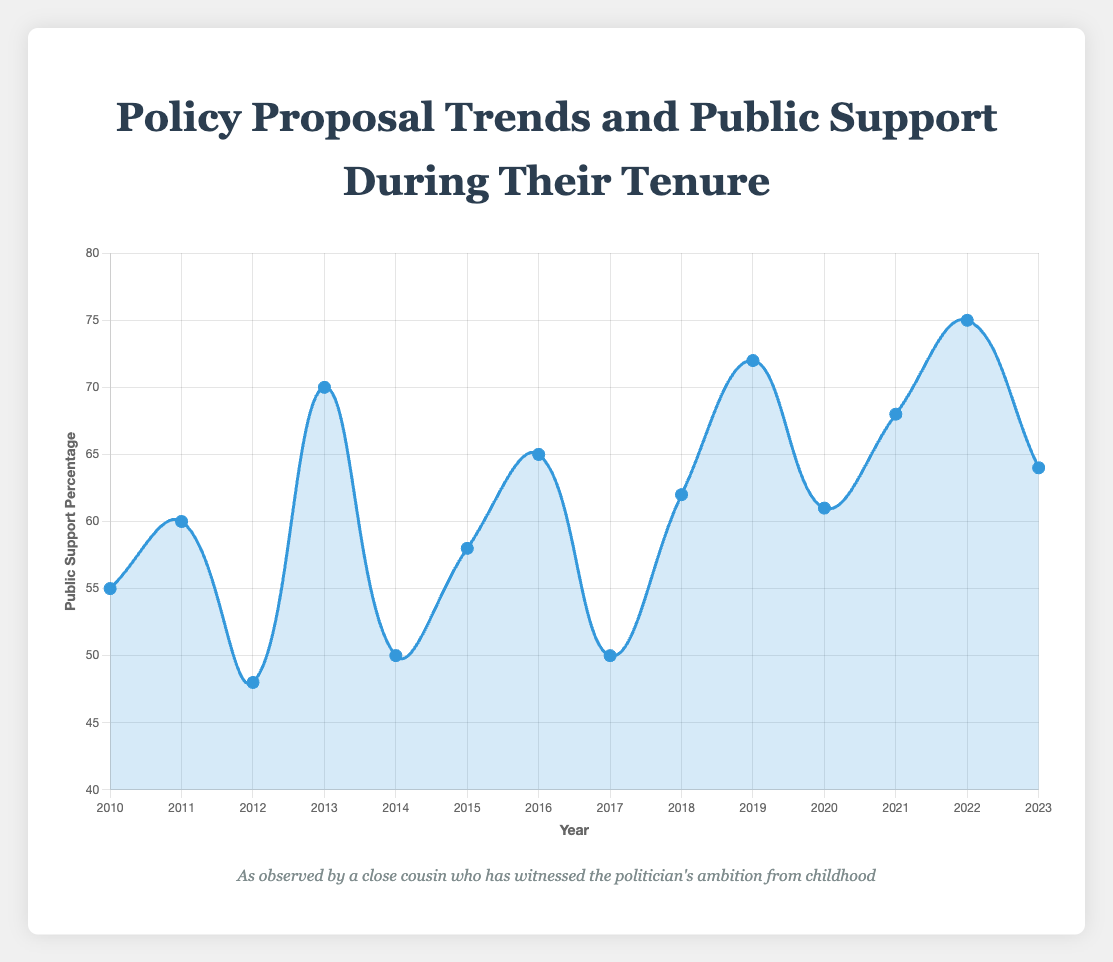How did public support change from 2010 to 2019? In 2010, public support was at 55%. By 2019, it had increased to 72%. This is calculated as a 17 percentage point increase.
Answer: Increased by 17 percentage points Which years had the highest and lowest public support percentages? The highest public support percentage was in 2022 at 75%, and the lowest was in 2012 at 48%.
Answer: 2022, 2012 What was the average public support percentage from 2015 to 2019? The public support percentages from 2015 to 2019 are 58%, 65%, 50%, 62%, and 72%. Adding them gives 307, and dividing by 5 gives an average of 61.4%.
Answer: 61.4% How did public support for healthcare reform policies change over the years depicted? In 2010, healthcare reform had 55% support. In 2015, it had 58% support, and in 2020, it had 61% support, indicating a steady increase.
Answer: Increased Compare the public support for environmental regulations in 2013 and 2019. In 2013, the support for environmental regulations was 70%, and in 2019, it was 72%. The support slightly increased by 2 percentage points.
Answer: 2 percentage points increase How did the introduction of the COVID-19 Relief Package in 2021 affect public support? In 2021, after the introduction of the COVID-19 Relief Package, public support was at 68%. Comparing with the previous years, there was a significant increase from the 62% in 2018 and 72% in 2019 to 61% in 2020.
Answer: Increased to 68% What was the public support trend for education funding policies over the years? Education funding had 60% support in 2011, increased to 62% in 2018, and slightly dropped to 64% in 2023. Overall, it shows a trend of increasing support.
Answer: Increasing trend How do public support percentages for tax reform compare between 2012 and 2017? In 2012, the support for tax reform was 48%, and in 2017, it increased to 50%, showing a slight increase of 2 percentage points.
Answer: Slightly increased by 2 percentage points What is the median public support percentage for the years shown? The public support percentages in ascending order are 48, 50, 50, 55, 58, 60, 61, 62, 64, 65, 68, 70, 72, 75. The median is the average of the 7th and 8th values, which are 61 and 62, giving a median of 61.5%.
Answer: 61.5% Which policy had the highest public support and in which year? The policy with the highest public support was "Infrastructure Investment" in 2022, with a support rate of 75%.
Answer: Infrastructure Investment in 2022 